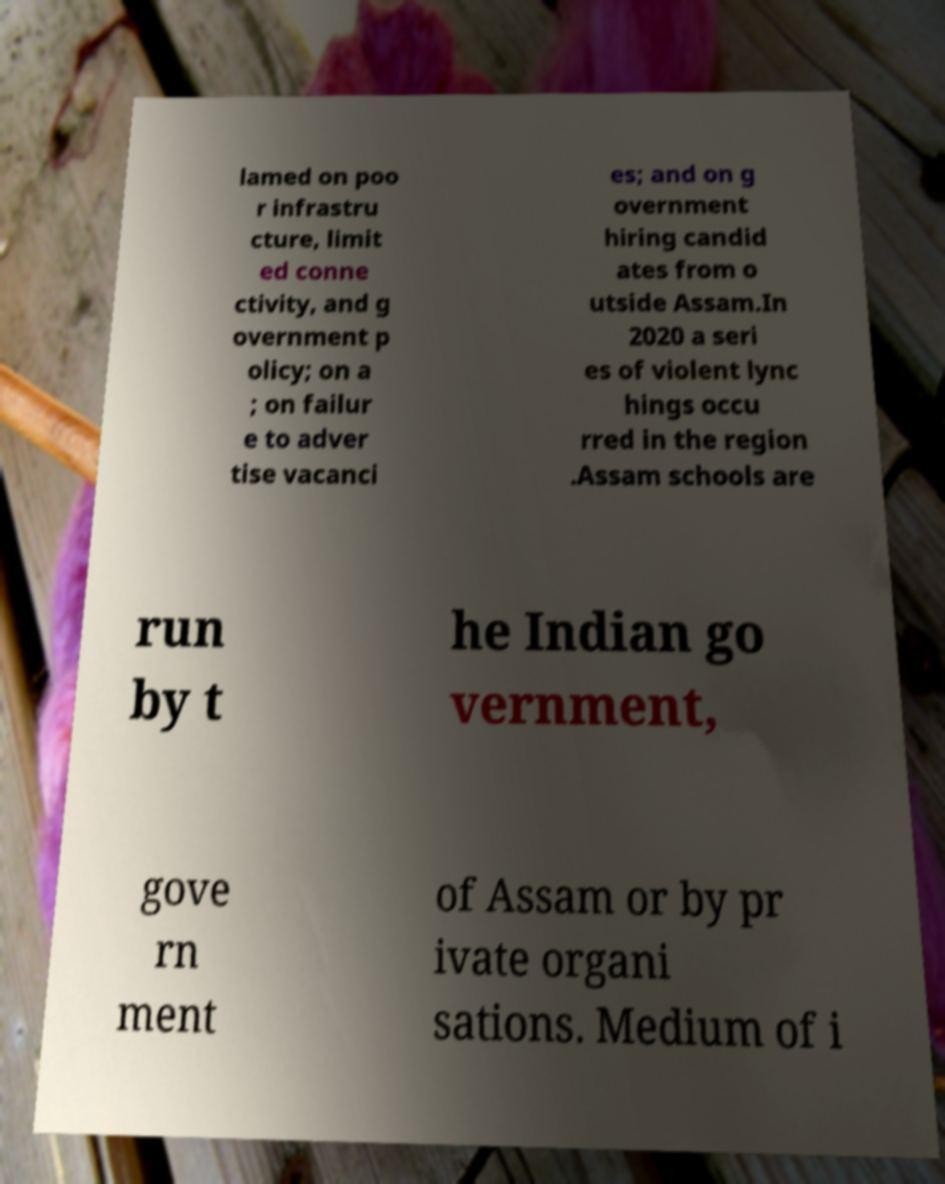There's text embedded in this image that I need extracted. Can you transcribe it verbatim? lamed on poo r infrastru cture, limit ed conne ctivity, and g overnment p olicy; on a ; on failur e to adver tise vacanci es; and on g overnment hiring candid ates from o utside Assam.In 2020 a seri es of violent lync hings occu rred in the region .Assam schools are run by t he Indian go vernment, gove rn ment of Assam or by pr ivate organi sations. Medium of i 